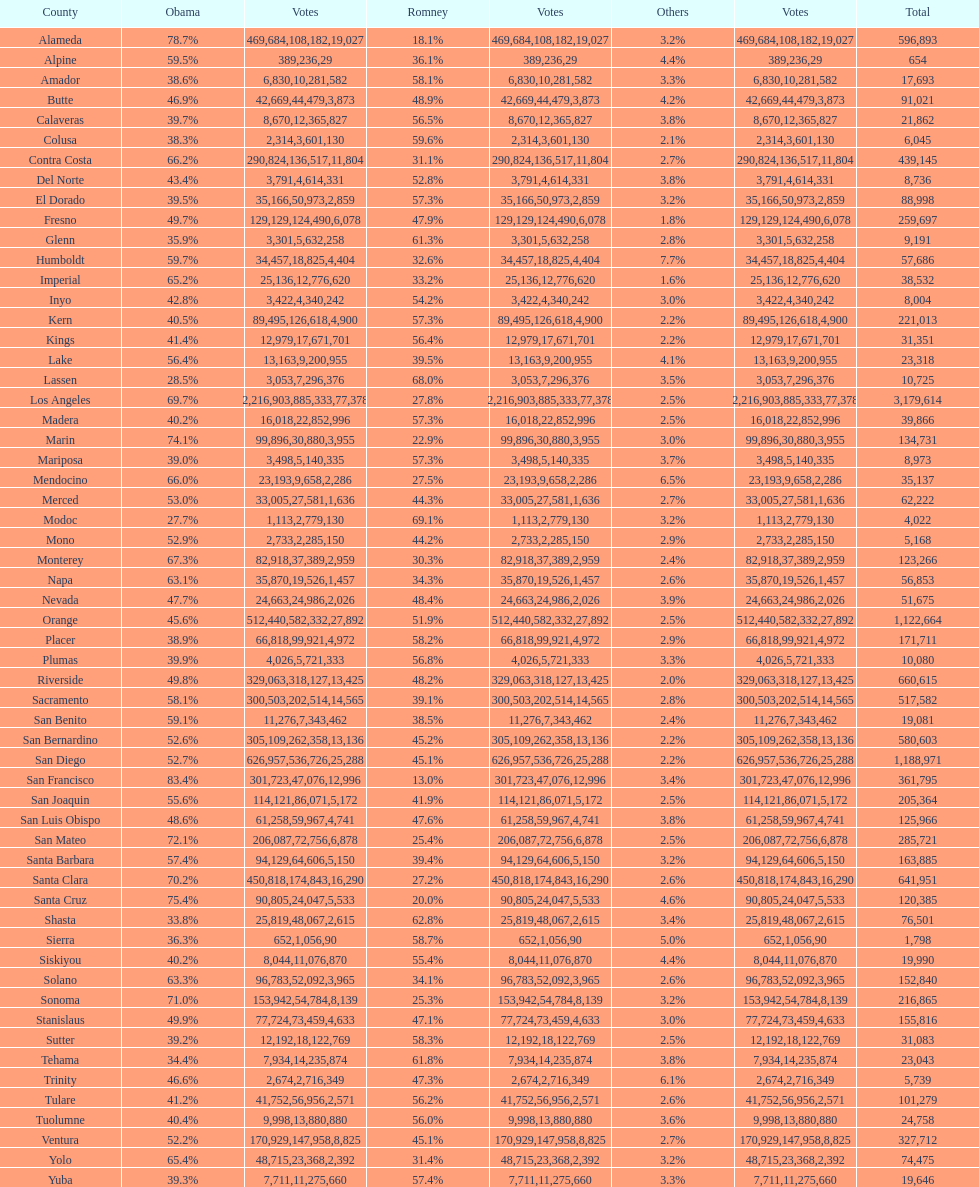Which county recorded the maximum total votes? Los Angeles. 